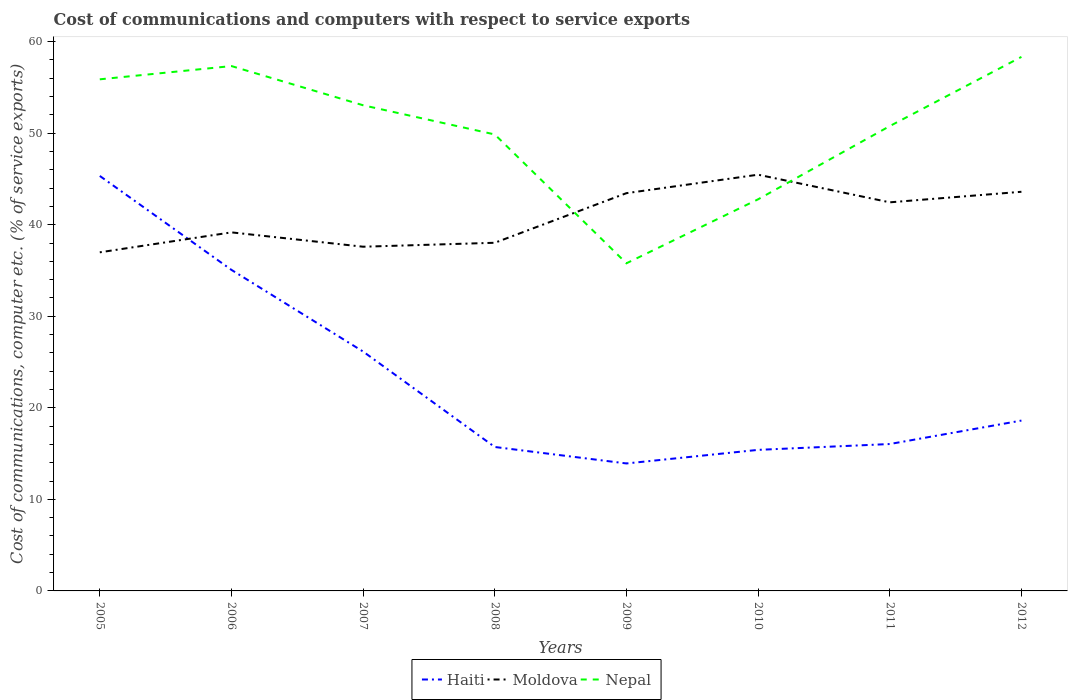How many different coloured lines are there?
Your answer should be very brief. 3. Across all years, what is the maximum cost of communications and computers in Moldova?
Your response must be concise. 36.99. What is the total cost of communications and computers in Haiti in the graph?
Offer a very short reply. -0.32. What is the difference between the highest and the second highest cost of communications and computers in Nepal?
Keep it short and to the point. 22.55. How many years are there in the graph?
Give a very brief answer. 8. Does the graph contain any zero values?
Keep it short and to the point. No. How are the legend labels stacked?
Keep it short and to the point. Horizontal. What is the title of the graph?
Keep it short and to the point. Cost of communications and computers with respect to service exports. Does "Ireland" appear as one of the legend labels in the graph?
Your response must be concise. No. What is the label or title of the X-axis?
Your answer should be compact. Years. What is the label or title of the Y-axis?
Offer a very short reply. Cost of communications, computer etc. (% of service exports). What is the Cost of communications, computer etc. (% of service exports) in Haiti in 2005?
Ensure brevity in your answer.  45.33. What is the Cost of communications, computer etc. (% of service exports) of Moldova in 2005?
Make the answer very short. 36.99. What is the Cost of communications, computer etc. (% of service exports) in Nepal in 2005?
Keep it short and to the point. 55.89. What is the Cost of communications, computer etc. (% of service exports) in Haiti in 2006?
Offer a terse response. 35.07. What is the Cost of communications, computer etc. (% of service exports) of Moldova in 2006?
Offer a terse response. 39.17. What is the Cost of communications, computer etc. (% of service exports) in Nepal in 2006?
Make the answer very short. 57.33. What is the Cost of communications, computer etc. (% of service exports) of Haiti in 2007?
Keep it short and to the point. 26.15. What is the Cost of communications, computer etc. (% of service exports) of Moldova in 2007?
Ensure brevity in your answer.  37.6. What is the Cost of communications, computer etc. (% of service exports) of Nepal in 2007?
Your response must be concise. 53.05. What is the Cost of communications, computer etc. (% of service exports) in Haiti in 2008?
Keep it short and to the point. 15.72. What is the Cost of communications, computer etc. (% of service exports) in Moldova in 2008?
Your answer should be very brief. 38.03. What is the Cost of communications, computer etc. (% of service exports) of Nepal in 2008?
Provide a short and direct response. 49.86. What is the Cost of communications, computer etc. (% of service exports) in Haiti in 2009?
Offer a very short reply. 13.92. What is the Cost of communications, computer etc. (% of service exports) of Moldova in 2009?
Your answer should be very brief. 43.45. What is the Cost of communications, computer etc. (% of service exports) in Nepal in 2009?
Provide a short and direct response. 35.79. What is the Cost of communications, computer etc. (% of service exports) of Haiti in 2010?
Your answer should be compact. 15.41. What is the Cost of communications, computer etc. (% of service exports) in Moldova in 2010?
Offer a terse response. 45.47. What is the Cost of communications, computer etc. (% of service exports) in Nepal in 2010?
Offer a very short reply. 42.78. What is the Cost of communications, computer etc. (% of service exports) of Haiti in 2011?
Offer a terse response. 16.05. What is the Cost of communications, computer etc. (% of service exports) of Moldova in 2011?
Offer a very short reply. 42.45. What is the Cost of communications, computer etc. (% of service exports) in Nepal in 2011?
Provide a short and direct response. 50.78. What is the Cost of communications, computer etc. (% of service exports) of Haiti in 2012?
Your answer should be compact. 18.61. What is the Cost of communications, computer etc. (% of service exports) in Moldova in 2012?
Offer a terse response. 43.6. What is the Cost of communications, computer etc. (% of service exports) in Nepal in 2012?
Your response must be concise. 58.33. Across all years, what is the maximum Cost of communications, computer etc. (% of service exports) of Haiti?
Offer a very short reply. 45.33. Across all years, what is the maximum Cost of communications, computer etc. (% of service exports) in Moldova?
Keep it short and to the point. 45.47. Across all years, what is the maximum Cost of communications, computer etc. (% of service exports) of Nepal?
Ensure brevity in your answer.  58.33. Across all years, what is the minimum Cost of communications, computer etc. (% of service exports) of Haiti?
Offer a terse response. 13.92. Across all years, what is the minimum Cost of communications, computer etc. (% of service exports) in Moldova?
Offer a terse response. 36.99. Across all years, what is the minimum Cost of communications, computer etc. (% of service exports) in Nepal?
Provide a short and direct response. 35.79. What is the total Cost of communications, computer etc. (% of service exports) of Haiti in the graph?
Make the answer very short. 186.26. What is the total Cost of communications, computer etc. (% of service exports) in Moldova in the graph?
Keep it short and to the point. 326.75. What is the total Cost of communications, computer etc. (% of service exports) of Nepal in the graph?
Your response must be concise. 403.81. What is the difference between the Cost of communications, computer etc. (% of service exports) of Haiti in 2005 and that in 2006?
Ensure brevity in your answer.  10.26. What is the difference between the Cost of communications, computer etc. (% of service exports) of Moldova in 2005 and that in 2006?
Give a very brief answer. -2.18. What is the difference between the Cost of communications, computer etc. (% of service exports) of Nepal in 2005 and that in 2006?
Your answer should be very brief. -1.45. What is the difference between the Cost of communications, computer etc. (% of service exports) in Haiti in 2005 and that in 2007?
Your response must be concise. 19.18. What is the difference between the Cost of communications, computer etc. (% of service exports) in Moldova in 2005 and that in 2007?
Offer a very short reply. -0.61. What is the difference between the Cost of communications, computer etc. (% of service exports) of Nepal in 2005 and that in 2007?
Provide a succinct answer. 2.83. What is the difference between the Cost of communications, computer etc. (% of service exports) of Haiti in 2005 and that in 2008?
Give a very brief answer. 29.61. What is the difference between the Cost of communications, computer etc. (% of service exports) in Moldova in 2005 and that in 2008?
Make the answer very short. -1.04. What is the difference between the Cost of communications, computer etc. (% of service exports) of Nepal in 2005 and that in 2008?
Give a very brief answer. 6.02. What is the difference between the Cost of communications, computer etc. (% of service exports) in Haiti in 2005 and that in 2009?
Give a very brief answer. 31.41. What is the difference between the Cost of communications, computer etc. (% of service exports) in Moldova in 2005 and that in 2009?
Your answer should be compact. -6.46. What is the difference between the Cost of communications, computer etc. (% of service exports) of Nepal in 2005 and that in 2009?
Your answer should be very brief. 20.1. What is the difference between the Cost of communications, computer etc. (% of service exports) of Haiti in 2005 and that in 2010?
Offer a very short reply. 29.92. What is the difference between the Cost of communications, computer etc. (% of service exports) in Moldova in 2005 and that in 2010?
Make the answer very short. -8.48. What is the difference between the Cost of communications, computer etc. (% of service exports) in Nepal in 2005 and that in 2010?
Your answer should be compact. 13.11. What is the difference between the Cost of communications, computer etc. (% of service exports) in Haiti in 2005 and that in 2011?
Offer a terse response. 29.29. What is the difference between the Cost of communications, computer etc. (% of service exports) in Moldova in 2005 and that in 2011?
Your response must be concise. -5.46. What is the difference between the Cost of communications, computer etc. (% of service exports) of Nepal in 2005 and that in 2011?
Your answer should be compact. 5.11. What is the difference between the Cost of communications, computer etc. (% of service exports) of Haiti in 2005 and that in 2012?
Your answer should be very brief. 26.72. What is the difference between the Cost of communications, computer etc. (% of service exports) of Moldova in 2005 and that in 2012?
Keep it short and to the point. -6.61. What is the difference between the Cost of communications, computer etc. (% of service exports) in Nepal in 2005 and that in 2012?
Offer a very short reply. -2.45. What is the difference between the Cost of communications, computer etc. (% of service exports) of Haiti in 2006 and that in 2007?
Offer a terse response. 8.92. What is the difference between the Cost of communications, computer etc. (% of service exports) in Moldova in 2006 and that in 2007?
Make the answer very short. 1.57. What is the difference between the Cost of communications, computer etc. (% of service exports) of Nepal in 2006 and that in 2007?
Ensure brevity in your answer.  4.28. What is the difference between the Cost of communications, computer etc. (% of service exports) in Haiti in 2006 and that in 2008?
Your response must be concise. 19.35. What is the difference between the Cost of communications, computer etc. (% of service exports) of Moldova in 2006 and that in 2008?
Give a very brief answer. 1.14. What is the difference between the Cost of communications, computer etc. (% of service exports) in Nepal in 2006 and that in 2008?
Provide a succinct answer. 7.47. What is the difference between the Cost of communications, computer etc. (% of service exports) in Haiti in 2006 and that in 2009?
Provide a succinct answer. 21.14. What is the difference between the Cost of communications, computer etc. (% of service exports) in Moldova in 2006 and that in 2009?
Provide a short and direct response. -4.28. What is the difference between the Cost of communications, computer etc. (% of service exports) of Nepal in 2006 and that in 2009?
Your response must be concise. 21.54. What is the difference between the Cost of communications, computer etc. (% of service exports) in Haiti in 2006 and that in 2010?
Your answer should be compact. 19.66. What is the difference between the Cost of communications, computer etc. (% of service exports) in Moldova in 2006 and that in 2010?
Ensure brevity in your answer.  -6.3. What is the difference between the Cost of communications, computer etc. (% of service exports) in Nepal in 2006 and that in 2010?
Provide a short and direct response. 14.56. What is the difference between the Cost of communications, computer etc. (% of service exports) of Haiti in 2006 and that in 2011?
Your answer should be compact. 19.02. What is the difference between the Cost of communications, computer etc. (% of service exports) of Moldova in 2006 and that in 2011?
Ensure brevity in your answer.  -3.28. What is the difference between the Cost of communications, computer etc. (% of service exports) in Nepal in 2006 and that in 2011?
Your answer should be very brief. 6.56. What is the difference between the Cost of communications, computer etc. (% of service exports) of Haiti in 2006 and that in 2012?
Your answer should be very brief. 16.46. What is the difference between the Cost of communications, computer etc. (% of service exports) of Moldova in 2006 and that in 2012?
Give a very brief answer. -4.43. What is the difference between the Cost of communications, computer etc. (% of service exports) in Nepal in 2006 and that in 2012?
Ensure brevity in your answer.  -1. What is the difference between the Cost of communications, computer etc. (% of service exports) in Haiti in 2007 and that in 2008?
Offer a terse response. 10.43. What is the difference between the Cost of communications, computer etc. (% of service exports) of Moldova in 2007 and that in 2008?
Ensure brevity in your answer.  -0.43. What is the difference between the Cost of communications, computer etc. (% of service exports) in Nepal in 2007 and that in 2008?
Offer a very short reply. 3.19. What is the difference between the Cost of communications, computer etc. (% of service exports) in Haiti in 2007 and that in 2009?
Provide a short and direct response. 12.22. What is the difference between the Cost of communications, computer etc. (% of service exports) of Moldova in 2007 and that in 2009?
Offer a very short reply. -5.85. What is the difference between the Cost of communications, computer etc. (% of service exports) in Nepal in 2007 and that in 2009?
Your answer should be compact. 17.26. What is the difference between the Cost of communications, computer etc. (% of service exports) in Haiti in 2007 and that in 2010?
Offer a very short reply. 10.74. What is the difference between the Cost of communications, computer etc. (% of service exports) in Moldova in 2007 and that in 2010?
Offer a terse response. -7.87. What is the difference between the Cost of communications, computer etc. (% of service exports) in Nepal in 2007 and that in 2010?
Keep it short and to the point. 10.27. What is the difference between the Cost of communications, computer etc. (% of service exports) in Haiti in 2007 and that in 2011?
Provide a succinct answer. 10.1. What is the difference between the Cost of communications, computer etc. (% of service exports) of Moldova in 2007 and that in 2011?
Offer a very short reply. -4.85. What is the difference between the Cost of communications, computer etc. (% of service exports) of Nepal in 2007 and that in 2011?
Provide a succinct answer. 2.27. What is the difference between the Cost of communications, computer etc. (% of service exports) of Haiti in 2007 and that in 2012?
Keep it short and to the point. 7.54. What is the difference between the Cost of communications, computer etc. (% of service exports) of Moldova in 2007 and that in 2012?
Your response must be concise. -6. What is the difference between the Cost of communications, computer etc. (% of service exports) in Nepal in 2007 and that in 2012?
Provide a short and direct response. -5.28. What is the difference between the Cost of communications, computer etc. (% of service exports) in Haiti in 2008 and that in 2009?
Make the answer very short. 1.8. What is the difference between the Cost of communications, computer etc. (% of service exports) in Moldova in 2008 and that in 2009?
Ensure brevity in your answer.  -5.42. What is the difference between the Cost of communications, computer etc. (% of service exports) of Nepal in 2008 and that in 2009?
Your response must be concise. 14.07. What is the difference between the Cost of communications, computer etc. (% of service exports) of Haiti in 2008 and that in 2010?
Provide a succinct answer. 0.31. What is the difference between the Cost of communications, computer etc. (% of service exports) in Moldova in 2008 and that in 2010?
Your response must be concise. -7.44. What is the difference between the Cost of communications, computer etc. (% of service exports) of Nepal in 2008 and that in 2010?
Give a very brief answer. 7.09. What is the difference between the Cost of communications, computer etc. (% of service exports) in Haiti in 2008 and that in 2011?
Offer a very short reply. -0.32. What is the difference between the Cost of communications, computer etc. (% of service exports) in Moldova in 2008 and that in 2011?
Your response must be concise. -4.42. What is the difference between the Cost of communications, computer etc. (% of service exports) of Nepal in 2008 and that in 2011?
Give a very brief answer. -0.91. What is the difference between the Cost of communications, computer etc. (% of service exports) of Haiti in 2008 and that in 2012?
Ensure brevity in your answer.  -2.89. What is the difference between the Cost of communications, computer etc. (% of service exports) of Moldova in 2008 and that in 2012?
Offer a very short reply. -5.57. What is the difference between the Cost of communications, computer etc. (% of service exports) of Nepal in 2008 and that in 2012?
Give a very brief answer. -8.47. What is the difference between the Cost of communications, computer etc. (% of service exports) of Haiti in 2009 and that in 2010?
Make the answer very short. -1.48. What is the difference between the Cost of communications, computer etc. (% of service exports) in Moldova in 2009 and that in 2010?
Your response must be concise. -2.02. What is the difference between the Cost of communications, computer etc. (% of service exports) in Nepal in 2009 and that in 2010?
Offer a terse response. -6.99. What is the difference between the Cost of communications, computer etc. (% of service exports) in Haiti in 2009 and that in 2011?
Give a very brief answer. -2.12. What is the difference between the Cost of communications, computer etc. (% of service exports) of Moldova in 2009 and that in 2011?
Offer a very short reply. 1. What is the difference between the Cost of communications, computer etc. (% of service exports) in Nepal in 2009 and that in 2011?
Give a very brief answer. -14.99. What is the difference between the Cost of communications, computer etc. (% of service exports) in Haiti in 2009 and that in 2012?
Your response must be concise. -4.68. What is the difference between the Cost of communications, computer etc. (% of service exports) in Moldova in 2009 and that in 2012?
Keep it short and to the point. -0.15. What is the difference between the Cost of communications, computer etc. (% of service exports) in Nepal in 2009 and that in 2012?
Offer a very short reply. -22.55. What is the difference between the Cost of communications, computer etc. (% of service exports) of Haiti in 2010 and that in 2011?
Your answer should be very brief. -0.64. What is the difference between the Cost of communications, computer etc. (% of service exports) of Moldova in 2010 and that in 2011?
Keep it short and to the point. 3.02. What is the difference between the Cost of communications, computer etc. (% of service exports) of Nepal in 2010 and that in 2011?
Give a very brief answer. -8. What is the difference between the Cost of communications, computer etc. (% of service exports) of Haiti in 2010 and that in 2012?
Your answer should be compact. -3.2. What is the difference between the Cost of communications, computer etc. (% of service exports) in Moldova in 2010 and that in 2012?
Offer a terse response. 1.87. What is the difference between the Cost of communications, computer etc. (% of service exports) in Nepal in 2010 and that in 2012?
Offer a terse response. -15.56. What is the difference between the Cost of communications, computer etc. (% of service exports) in Haiti in 2011 and that in 2012?
Your answer should be very brief. -2.56. What is the difference between the Cost of communications, computer etc. (% of service exports) in Moldova in 2011 and that in 2012?
Offer a very short reply. -1.15. What is the difference between the Cost of communications, computer etc. (% of service exports) in Nepal in 2011 and that in 2012?
Your answer should be very brief. -7.56. What is the difference between the Cost of communications, computer etc. (% of service exports) of Haiti in 2005 and the Cost of communications, computer etc. (% of service exports) of Moldova in 2006?
Make the answer very short. 6.17. What is the difference between the Cost of communications, computer etc. (% of service exports) in Haiti in 2005 and the Cost of communications, computer etc. (% of service exports) in Nepal in 2006?
Your answer should be compact. -12. What is the difference between the Cost of communications, computer etc. (% of service exports) in Moldova in 2005 and the Cost of communications, computer etc. (% of service exports) in Nepal in 2006?
Provide a short and direct response. -20.35. What is the difference between the Cost of communications, computer etc. (% of service exports) in Haiti in 2005 and the Cost of communications, computer etc. (% of service exports) in Moldova in 2007?
Your response must be concise. 7.73. What is the difference between the Cost of communications, computer etc. (% of service exports) of Haiti in 2005 and the Cost of communications, computer etc. (% of service exports) of Nepal in 2007?
Your answer should be very brief. -7.72. What is the difference between the Cost of communications, computer etc. (% of service exports) in Moldova in 2005 and the Cost of communications, computer etc. (% of service exports) in Nepal in 2007?
Give a very brief answer. -16.06. What is the difference between the Cost of communications, computer etc. (% of service exports) of Haiti in 2005 and the Cost of communications, computer etc. (% of service exports) of Moldova in 2008?
Ensure brevity in your answer.  7.3. What is the difference between the Cost of communications, computer etc. (% of service exports) in Haiti in 2005 and the Cost of communications, computer etc. (% of service exports) in Nepal in 2008?
Keep it short and to the point. -4.53. What is the difference between the Cost of communications, computer etc. (% of service exports) of Moldova in 2005 and the Cost of communications, computer etc. (% of service exports) of Nepal in 2008?
Ensure brevity in your answer.  -12.88. What is the difference between the Cost of communications, computer etc. (% of service exports) of Haiti in 2005 and the Cost of communications, computer etc. (% of service exports) of Moldova in 2009?
Keep it short and to the point. 1.88. What is the difference between the Cost of communications, computer etc. (% of service exports) of Haiti in 2005 and the Cost of communications, computer etc. (% of service exports) of Nepal in 2009?
Your answer should be very brief. 9.54. What is the difference between the Cost of communications, computer etc. (% of service exports) of Moldova in 2005 and the Cost of communications, computer etc. (% of service exports) of Nepal in 2009?
Give a very brief answer. 1.2. What is the difference between the Cost of communications, computer etc. (% of service exports) in Haiti in 2005 and the Cost of communications, computer etc. (% of service exports) in Moldova in 2010?
Provide a succinct answer. -0.14. What is the difference between the Cost of communications, computer etc. (% of service exports) in Haiti in 2005 and the Cost of communications, computer etc. (% of service exports) in Nepal in 2010?
Keep it short and to the point. 2.55. What is the difference between the Cost of communications, computer etc. (% of service exports) of Moldova in 2005 and the Cost of communications, computer etc. (% of service exports) of Nepal in 2010?
Your answer should be compact. -5.79. What is the difference between the Cost of communications, computer etc. (% of service exports) in Haiti in 2005 and the Cost of communications, computer etc. (% of service exports) in Moldova in 2011?
Provide a succinct answer. 2.88. What is the difference between the Cost of communications, computer etc. (% of service exports) in Haiti in 2005 and the Cost of communications, computer etc. (% of service exports) in Nepal in 2011?
Make the answer very short. -5.44. What is the difference between the Cost of communications, computer etc. (% of service exports) of Moldova in 2005 and the Cost of communications, computer etc. (% of service exports) of Nepal in 2011?
Your response must be concise. -13.79. What is the difference between the Cost of communications, computer etc. (% of service exports) of Haiti in 2005 and the Cost of communications, computer etc. (% of service exports) of Moldova in 2012?
Offer a terse response. 1.73. What is the difference between the Cost of communications, computer etc. (% of service exports) in Haiti in 2005 and the Cost of communications, computer etc. (% of service exports) in Nepal in 2012?
Ensure brevity in your answer.  -13. What is the difference between the Cost of communications, computer etc. (% of service exports) of Moldova in 2005 and the Cost of communications, computer etc. (% of service exports) of Nepal in 2012?
Provide a short and direct response. -21.35. What is the difference between the Cost of communications, computer etc. (% of service exports) of Haiti in 2006 and the Cost of communications, computer etc. (% of service exports) of Moldova in 2007?
Offer a terse response. -2.53. What is the difference between the Cost of communications, computer etc. (% of service exports) of Haiti in 2006 and the Cost of communications, computer etc. (% of service exports) of Nepal in 2007?
Keep it short and to the point. -17.98. What is the difference between the Cost of communications, computer etc. (% of service exports) in Moldova in 2006 and the Cost of communications, computer etc. (% of service exports) in Nepal in 2007?
Your answer should be very brief. -13.88. What is the difference between the Cost of communications, computer etc. (% of service exports) in Haiti in 2006 and the Cost of communications, computer etc. (% of service exports) in Moldova in 2008?
Your answer should be compact. -2.96. What is the difference between the Cost of communications, computer etc. (% of service exports) of Haiti in 2006 and the Cost of communications, computer etc. (% of service exports) of Nepal in 2008?
Keep it short and to the point. -14.79. What is the difference between the Cost of communications, computer etc. (% of service exports) of Moldova in 2006 and the Cost of communications, computer etc. (% of service exports) of Nepal in 2008?
Offer a terse response. -10.7. What is the difference between the Cost of communications, computer etc. (% of service exports) of Haiti in 2006 and the Cost of communications, computer etc. (% of service exports) of Moldova in 2009?
Your response must be concise. -8.38. What is the difference between the Cost of communications, computer etc. (% of service exports) of Haiti in 2006 and the Cost of communications, computer etc. (% of service exports) of Nepal in 2009?
Your answer should be compact. -0.72. What is the difference between the Cost of communications, computer etc. (% of service exports) in Moldova in 2006 and the Cost of communications, computer etc. (% of service exports) in Nepal in 2009?
Keep it short and to the point. 3.38. What is the difference between the Cost of communications, computer etc. (% of service exports) of Haiti in 2006 and the Cost of communications, computer etc. (% of service exports) of Moldova in 2010?
Keep it short and to the point. -10.4. What is the difference between the Cost of communications, computer etc. (% of service exports) of Haiti in 2006 and the Cost of communications, computer etc. (% of service exports) of Nepal in 2010?
Give a very brief answer. -7.71. What is the difference between the Cost of communications, computer etc. (% of service exports) in Moldova in 2006 and the Cost of communications, computer etc. (% of service exports) in Nepal in 2010?
Give a very brief answer. -3.61. What is the difference between the Cost of communications, computer etc. (% of service exports) of Haiti in 2006 and the Cost of communications, computer etc. (% of service exports) of Moldova in 2011?
Keep it short and to the point. -7.38. What is the difference between the Cost of communications, computer etc. (% of service exports) in Haiti in 2006 and the Cost of communications, computer etc. (% of service exports) in Nepal in 2011?
Give a very brief answer. -15.71. What is the difference between the Cost of communications, computer etc. (% of service exports) of Moldova in 2006 and the Cost of communications, computer etc. (% of service exports) of Nepal in 2011?
Provide a succinct answer. -11.61. What is the difference between the Cost of communications, computer etc. (% of service exports) in Haiti in 2006 and the Cost of communications, computer etc. (% of service exports) in Moldova in 2012?
Provide a succinct answer. -8.53. What is the difference between the Cost of communications, computer etc. (% of service exports) in Haiti in 2006 and the Cost of communications, computer etc. (% of service exports) in Nepal in 2012?
Make the answer very short. -23.27. What is the difference between the Cost of communications, computer etc. (% of service exports) in Moldova in 2006 and the Cost of communications, computer etc. (% of service exports) in Nepal in 2012?
Offer a terse response. -19.17. What is the difference between the Cost of communications, computer etc. (% of service exports) in Haiti in 2007 and the Cost of communications, computer etc. (% of service exports) in Moldova in 2008?
Ensure brevity in your answer.  -11.88. What is the difference between the Cost of communications, computer etc. (% of service exports) in Haiti in 2007 and the Cost of communications, computer etc. (% of service exports) in Nepal in 2008?
Your answer should be compact. -23.72. What is the difference between the Cost of communications, computer etc. (% of service exports) in Moldova in 2007 and the Cost of communications, computer etc. (% of service exports) in Nepal in 2008?
Give a very brief answer. -12.26. What is the difference between the Cost of communications, computer etc. (% of service exports) in Haiti in 2007 and the Cost of communications, computer etc. (% of service exports) in Moldova in 2009?
Your response must be concise. -17.3. What is the difference between the Cost of communications, computer etc. (% of service exports) of Haiti in 2007 and the Cost of communications, computer etc. (% of service exports) of Nepal in 2009?
Your response must be concise. -9.64. What is the difference between the Cost of communications, computer etc. (% of service exports) of Moldova in 2007 and the Cost of communications, computer etc. (% of service exports) of Nepal in 2009?
Your answer should be very brief. 1.81. What is the difference between the Cost of communications, computer etc. (% of service exports) in Haiti in 2007 and the Cost of communications, computer etc. (% of service exports) in Moldova in 2010?
Offer a very short reply. -19.32. What is the difference between the Cost of communications, computer etc. (% of service exports) in Haiti in 2007 and the Cost of communications, computer etc. (% of service exports) in Nepal in 2010?
Give a very brief answer. -16.63. What is the difference between the Cost of communications, computer etc. (% of service exports) of Moldova in 2007 and the Cost of communications, computer etc. (% of service exports) of Nepal in 2010?
Provide a short and direct response. -5.18. What is the difference between the Cost of communications, computer etc. (% of service exports) of Haiti in 2007 and the Cost of communications, computer etc. (% of service exports) of Moldova in 2011?
Offer a very short reply. -16.3. What is the difference between the Cost of communications, computer etc. (% of service exports) of Haiti in 2007 and the Cost of communications, computer etc. (% of service exports) of Nepal in 2011?
Your answer should be very brief. -24.63. What is the difference between the Cost of communications, computer etc. (% of service exports) of Moldova in 2007 and the Cost of communications, computer etc. (% of service exports) of Nepal in 2011?
Your response must be concise. -13.18. What is the difference between the Cost of communications, computer etc. (% of service exports) in Haiti in 2007 and the Cost of communications, computer etc. (% of service exports) in Moldova in 2012?
Provide a short and direct response. -17.45. What is the difference between the Cost of communications, computer etc. (% of service exports) in Haiti in 2007 and the Cost of communications, computer etc. (% of service exports) in Nepal in 2012?
Your answer should be compact. -32.19. What is the difference between the Cost of communications, computer etc. (% of service exports) in Moldova in 2007 and the Cost of communications, computer etc. (% of service exports) in Nepal in 2012?
Offer a terse response. -20.73. What is the difference between the Cost of communications, computer etc. (% of service exports) of Haiti in 2008 and the Cost of communications, computer etc. (% of service exports) of Moldova in 2009?
Ensure brevity in your answer.  -27.73. What is the difference between the Cost of communications, computer etc. (% of service exports) of Haiti in 2008 and the Cost of communications, computer etc. (% of service exports) of Nepal in 2009?
Ensure brevity in your answer.  -20.07. What is the difference between the Cost of communications, computer etc. (% of service exports) of Moldova in 2008 and the Cost of communications, computer etc. (% of service exports) of Nepal in 2009?
Provide a short and direct response. 2.24. What is the difference between the Cost of communications, computer etc. (% of service exports) in Haiti in 2008 and the Cost of communications, computer etc. (% of service exports) in Moldova in 2010?
Offer a terse response. -29.75. What is the difference between the Cost of communications, computer etc. (% of service exports) in Haiti in 2008 and the Cost of communications, computer etc. (% of service exports) in Nepal in 2010?
Offer a terse response. -27.06. What is the difference between the Cost of communications, computer etc. (% of service exports) of Moldova in 2008 and the Cost of communications, computer etc. (% of service exports) of Nepal in 2010?
Your answer should be compact. -4.75. What is the difference between the Cost of communications, computer etc. (% of service exports) in Haiti in 2008 and the Cost of communications, computer etc. (% of service exports) in Moldova in 2011?
Offer a terse response. -26.73. What is the difference between the Cost of communications, computer etc. (% of service exports) of Haiti in 2008 and the Cost of communications, computer etc. (% of service exports) of Nepal in 2011?
Your answer should be very brief. -35.05. What is the difference between the Cost of communications, computer etc. (% of service exports) of Moldova in 2008 and the Cost of communications, computer etc. (% of service exports) of Nepal in 2011?
Provide a short and direct response. -12.75. What is the difference between the Cost of communications, computer etc. (% of service exports) in Haiti in 2008 and the Cost of communications, computer etc. (% of service exports) in Moldova in 2012?
Make the answer very short. -27.88. What is the difference between the Cost of communications, computer etc. (% of service exports) of Haiti in 2008 and the Cost of communications, computer etc. (% of service exports) of Nepal in 2012?
Give a very brief answer. -42.61. What is the difference between the Cost of communications, computer etc. (% of service exports) in Moldova in 2008 and the Cost of communications, computer etc. (% of service exports) in Nepal in 2012?
Ensure brevity in your answer.  -20.3. What is the difference between the Cost of communications, computer etc. (% of service exports) in Haiti in 2009 and the Cost of communications, computer etc. (% of service exports) in Moldova in 2010?
Make the answer very short. -31.54. What is the difference between the Cost of communications, computer etc. (% of service exports) in Haiti in 2009 and the Cost of communications, computer etc. (% of service exports) in Nepal in 2010?
Provide a succinct answer. -28.85. What is the difference between the Cost of communications, computer etc. (% of service exports) of Moldova in 2009 and the Cost of communications, computer etc. (% of service exports) of Nepal in 2010?
Give a very brief answer. 0.67. What is the difference between the Cost of communications, computer etc. (% of service exports) in Haiti in 2009 and the Cost of communications, computer etc. (% of service exports) in Moldova in 2011?
Make the answer very short. -28.52. What is the difference between the Cost of communications, computer etc. (% of service exports) of Haiti in 2009 and the Cost of communications, computer etc. (% of service exports) of Nepal in 2011?
Your response must be concise. -36.85. What is the difference between the Cost of communications, computer etc. (% of service exports) in Moldova in 2009 and the Cost of communications, computer etc. (% of service exports) in Nepal in 2011?
Your answer should be very brief. -7.33. What is the difference between the Cost of communications, computer etc. (% of service exports) of Haiti in 2009 and the Cost of communications, computer etc. (% of service exports) of Moldova in 2012?
Your answer should be compact. -29.68. What is the difference between the Cost of communications, computer etc. (% of service exports) in Haiti in 2009 and the Cost of communications, computer etc. (% of service exports) in Nepal in 2012?
Your answer should be very brief. -44.41. What is the difference between the Cost of communications, computer etc. (% of service exports) in Moldova in 2009 and the Cost of communications, computer etc. (% of service exports) in Nepal in 2012?
Give a very brief answer. -14.88. What is the difference between the Cost of communications, computer etc. (% of service exports) of Haiti in 2010 and the Cost of communications, computer etc. (% of service exports) of Moldova in 2011?
Keep it short and to the point. -27.04. What is the difference between the Cost of communications, computer etc. (% of service exports) of Haiti in 2010 and the Cost of communications, computer etc. (% of service exports) of Nepal in 2011?
Offer a very short reply. -35.37. What is the difference between the Cost of communications, computer etc. (% of service exports) of Moldova in 2010 and the Cost of communications, computer etc. (% of service exports) of Nepal in 2011?
Your response must be concise. -5.31. What is the difference between the Cost of communications, computer etc. (% of service exports) in Haiti in 2010 and the Cost of communications, computer etc. (% of service exports) in Moldova in 2012?
Offer a very short reply. -28.19. What is the difference between the Cost of communications, computer etc. (% of service exports) in Haiti in 2010 and the Cost of communications, computer etc. (% of service exports) in Nepal in 2012?
Your answer should be very brief. -42.93. What is the difference between the Cost of communications, computer etc. (% of service exports) in Moldova in 2010 and the Cost of communications, computer etc. (% of service exports) in Nepal in 2012?
Your response must be concise. -12.87. What is the difference between the Cost of communications, computer etc. (% of service exports) in Haiti in 2011 and the Cost of communications, computer etc. (% of service exports) in Moldova in 2012?
Keep it short and to the point. -27.56. What is the difference between the Cost of communications, computer etc. (% of service exports) of Haiti in 2011 and the Cost of communications, computer etc. (% of service exports) of Nepal in 2012?
Keep it short and to the point. -42.29. What is the difference between the Cost of communications, computer etc. (% of service exports) in Moldova in 2011 and the Cost of communications, computer etc. (% of service exports) in Nepal in 2012?
Offer a terse response. -15.89. What is the average Cost of communications, computer etc. (% of service exports) in Haiti per year?
Your answer should be compact. 23.28. What is the average Cost of communications, computer etc. (% of service exports) of Moldova per year?
Provide a succinct answer. 40.84. What is the average Cost of communications, computer etc. (% of service exports) of Nepal per year?
Offer a very short reply. 50.48. In the year 2005, what is the difference between the Cost of communications, computer etc. (% of service exports) in Haiti and Cost of communications, computer etc. (% of service exports) in Moldova?
Your answer should be very brief. 8.34. In the year 2005, what is the difference between the Cost of communications, computer etc. (% of service exports) in Haiti and Cost of communications, computer etc. (% of service exports) in Nepal?
Make the answer very short. -10.55. In the year 2005, what is the difference between the Cost of communications, computer etc. (% of service exports) of Moldova and Cost of communications, computer etc. (% of service exports) of Nepal?
Offer a terse response. -18.9. In the year 2006, what is the difference between the Cost of communications, computer etc. (% of service exports) of Haiti and Cost of communications, computer etc. (% of service exports) of Moldova?
Provide a succinct answer. -4.1. In the year 2006, what is the difference between the Cost of communications, computer etc. (% of service exports) in Haiti and Cost of communications, computer etc. (% of service exports) in Nepal?
Make the answer very short. -22.26. In the year 2006, what is the difference between the Cost of communications, computer etc. (% of service exports) of Moldova and Cost of communications, computer etc. (% of service exports) of Nepal?
Keep it short and to the point. -18.17. In the year 2007, what is the difference between the Cost of communications, computer etc. (% of service exports) of Haiti and Cost of communications, computer etc. (% of service exports) of Moldova?
Ensure brevity in your answer.  -11.45. In the year 2007, what is the difference between the Cost of communications, computer etc. (% of service exports) of Haiti and Cost of communications, computer etc. (% of service exports) of Nepal?
Ensure brevity in your answer.  -26.9. In the year 2007, what is the difference between the Cost of communications, computer etc. (% of service exports) of Moldova and Cost of communications, computer etc. (% of service exports) of Nepal?
Offer a terse response. -15.45. In the year 2008, what is the difference between the Cost of communications, computer etc. (% of service exports) of Haiti and Cost of communications, computer etc. (% of service exports) of Moldova?
Make the answer very short. -22.31. In the year 2008, what is the difference between the Cost of communications, computer etc. (% of service exports) in Haiti and Cost of communications, computer etc. (% of service exports) in Nepal?
Keep it short and to the point. -34.14. In the year 2008, what is the difference between the Cost of communications, computer etc. (% of service exports) of Moldova and Cost of communications, computer etc. (% of service exports) of Nepal?
Your answer should be very brief. -11.83. In the year 2009, what is the difference between the Cost of communications, computer etc. (% of service exports) of Haiti and Cost of communications, computer etc. (% of service exports) of Moldova?
Your response must be concise. -29.53. In the year 2009, what is the difference between the Cost of communications, computer etc. (% of service exports) in Haiti and Cost of communications, computer etc. (% of service exports) in Nepal?
Offer a terse response. -21.86. In the year 2009, what is the difference between the Cost of communications, computer etc. (% of service exports) of Moldova and Cost of communications, computer etc. (% of service exports) of Nepal?
Offer a very short reply. 7.66. In the year 2010, what is the difference between the Cost of communications, computer etc. (% of service exports) in Haiti and Cost of communications, computer etc. (% of service exports) in Moldova?
Ensure brevity in your answer.  -30.06. In the year 2010, what is the difference between the Cost of communications, computer etc. (% of service exports) of Haiti and Cost of communications, computer etc. (% of service exports) of Nepal?
Offer a very short reply. -27.37. In the year 2010, what is the difference between the Cost of communications, computer etc. (% of service exports) of Moldova and Cost of communications, computer etc. (% of service exports) of Nepal?
Offer a very short reply. 2.69. In the year 2011, what is the difference between the Cost of communications, computer etc. (% of service exports) of Haiti and Cost of communications, computer etc. (% of service exports) of Moldova?
Your answer should be very brief. -26.4. In the year 2011, what is the difference between the Cost of communications, computer etc. (% of service exports) in Haiti and Cost of communications, computer etc. (% of service exports) in Nepal?
Offer a very short reply. -34.73. In the year 2011, what is the difference between the Cost of communications, computer etc. (% of service exports) in Moldova and Cost of communications, computer etc. (% of service exports) in Nepal?
Keep it short and to the point. -8.33. In the year 2012, what is the difference between the Cost of communications, computer etc. (% of service exports) in Haiti and Cost of communications, computer etc. (% of service exports) in Moldova?
Give a very brief answer. -24.99. In the year 2012, what is the difference between the Cost of communications, computer etc. (% of service exports) in Haiti and Cost of communications, computer etc. (% of service exports) in Nepal?
Your response must be concise. -39.73. In the year 2012, what is the difference between the Cost of communications, computer etc. (% of service exports) in Moldova and Cost of communications, computer etc. (% of service exports) in Nepal?
Your answer should be compact. -14.73. What is the ratio of the Cost of communications, computer etc. (% of service exports) of Haiti in 2005 to that in 2006?
Provide a succinct answer. 1.29. What is the ratio of the Cost of communications, computer etc. (% of service exports) in Nepal in 2005 to that in 2006?
Offer a terse response. 0.97. What is the ratio of the Cost of communications, computer etc. (% of service exports) of Haiti in 2005 to that in 2007?
Your answer should be very brief. 1.73. What is the ratio of the Cost of communications, computer etc. (% of service exports) of Moldova in 2005 to that in 2007?
Offer a terse response. 0.98. What is the ratio of the Cost of communications, computer etc. (% of service exports) of Nepal in 2005 to that in 2007?
Give a very brief answer. 1.05. What is the ratio of the Cost of communications, computer etc. (% of service exports) in Haiti in 2005 to that in 2008?
Provide a succinct answer. 2.88. What is the ratio of the Cost of communications, computer etc. (% of service exports) of Moldova in 2005 to that in 2008?
Offer a terse response. 0.97. What is the ratio of the Cost of communications, computer etc. (% of service exports) of Nepal in 2005 to that in 2008?
Offer a terse response. 1.12. What is the ratio of the Cost of communications, computer etc. (% of service exports) in Haiti in 2005 to that in 2009?
Provide a succinct answer. 3.26. What is the ratio of the Cost of communications, computer etc. (% of service exports) of Moldova in 2005 to that in 2009?
Provide a short and direct response. 0.85. What is the ratio of the Cost of communications, computer etc. (% of service exports) of Nepal in 2005 to that in 2009?
Provide a succinct answer. 1.56. What is the ratio of the Cost of communications, computer etc. (% of service exports) in Haiti in 2005 to that in 2010?
Offer a very short reply. 2.94. What is the ratio of the Cost of communications, computer etc. (% of service exports) in Moldova in 2005 to that in 2010?
Give a very brief answer. 0.81. What is the ratio of the Cost of communications, computer etc. (% of service exports) of Nepal in 2005 to that in 2010?
Provide a succinct answer. 1.31. What is the ratio of the Cost of communications, computer etc. (% of service exports) of Haiti in 2005 to that in 2011?
Your answer should be compact. 2.83. What is the ratio of the Cost of communications, computer etc. (% of service exports) of Moldova in 2005 to that in 2011?
Give a very brief answer. 0.87. What is the ratio of the Cost of communications, computer etc. (% of service exports) in Nepal in 2005 to that in 2011?
Make the answer very short. 1.1. What is the ratio of the Cost of communications, computer etc. (% of service exports) in Haiti in 2005 to that in 2012?
Your response must be concise. 2.44. What is the ratio of the Cost of communications, computer etc. (% of service exports) of Moldova in 2005 to that in 2012?
Your answer should be very brief. 0.85. What is the ratio of the Cost of communications, computer etc. (% of service exports) of Nepal in 2005 to that in 2012?
Offer a terse response. 0.96. What is the ratio of the Cost of communications, computer etc. (% of service exports) in Haiti in 2006 to that in 2007?
Keep it short and to the point. 1.34. What is the ratio of the Cost of communications, computer etc. (% of service exports) of Moldova in 2006 to that in 2007?
Make the answer very short. 1.04. What is the ratio of the Cost of communications, computer etc. (% of service exports) of Nepal in 2006 to that in 2007?
Offer a terse response. 1.08. What is the ratio of the Cost of communications, computer etc. (% of service exports) of Haiti in 2006 to that in 2008?
Make the answer very short. 2.23. What is the ratio of the Cost of communications, computer etc. (% of service exports) in Moldova in 2006 to that in 2008?
Your answer should be compact. 1.03. What is the ratio of the Cost of communications, computer etc. (% of service exports) in Nepal in 2006 to that in 2008?
Offer a terse response. 1.15. What is the ratio of the Cost of communications, computer etc. (% of service exports) of Haiti in 2006 to that in 2009?
Your response must be concise. 2.52. What is the ratio of the Cost of communications, computer etc. (% of service exports) of Moldova in 2006 to that in 2009?
Give a very brief answer. 0.9. What is the ratio of the Cost of communications, computer etc. (% of service exports) in Nepal in 2006 to that in 2009?
Make the answer very short. 1.6. What is the ratio of the Cost of communications, computer etc. (% of service exports) in Haiti in 2006 to that in 2010?
Offer a very short reply. 2.28. What is the ratio of the Cost of communications, computer etc. (% of service exports) of Moldova in 2006 to that in 2010?
Provide a short and direct response. 0.86. What is the ratio of the Cost of communications, computer etc. (% of service exports) in Nepal in 2006 to that in 2010?
Provide a short and direct response. 1.34. What is the ratio of the Cost of communications, computer etc. (% of service exports) in Haiti in 2006 to that in 2011?
Ensure brevity in your answer.  2.19. What is the ratio of the Cost of communications, computer etc. (% of service exports) in Moldova in 2006 to that in 2011?
Your answer should be compact. 0.92. What is the ratio of the Cost of communications, computer etc. (% of service exports) of Nepal in 2006 to that in 2011?
Your answer should be compact. 1.13. What is the ratio of the Cost of communications, computer etc. (% of service exports) in Haiti in 2006 to that in 2012?
Keep it short and to the point. 1.88. What is the ratio of the Cost of communications, computer etc. (% of service exports) in Moldova in 2006 to that in 2012?
Your response must be concise. 0.9. What is the ratio of the Cost of communications, computer etc. (% of service exports) of Nepal in 2006 to that in 2012?
Provide a succinct answer. 0.98. What is the ratio of the Cost of communications, computer etc. (% of service exports) of Haiti in 2007 to that in 2008?
Your answer should be compact. 1.66. What is the ratio of the Cost of communications, computer etc. (% of service exports) in Moldova in 2007 to that in 2008?
Ensure brevity in your answer.  0.99. What is the ratio of the Cost of communications, computer etc. (% of service exports) of Nepal in 2007 to that in 2008?
Offer a very short reply. 1.06. What is the ratio of the Cost of communications, computer etc. (% of service exports) of Haiti in 2007 to that in 2009?
Provide a short and direct response. 1.88. What is the ratio of the Cost of communications, computer etc. (% of service exports) in Moldova in 2007 to that in 2009?
Your answer should be compact. 0.87. What is the ratio of the Cost of communications, computer etc. (% of service exports) of Nepal in 2007 to that in 2009?
Make the answer very short. 1.48. What is the ratio of the Cost of communications, computer etc. (% of service exports) of Haiti in 2007 to that in 2010?
Offer a terse response. 1.7. What is the ratio of the Cost of communications, computer etc. (% of service exports) in Moldova in 2007 to that in 2010?
Make the answer very short. 0.83. What is the ratio of the Cost of communications, computer etc. (% of service exports) of Nepal in 2007 to that in 2010?
Your answer should be compact. 1.24. What is the ratio of the Cost of communications, computer etc. (% of service exports) of Haiti in 2007 to that in 2011?
Keep it short and to the point. 1.63. What is the ratio of the Cost of communications, computer etc. (% of service exports) in Moldova in 2007 to that in 2011?
Provide a succinct answer. 0.89. What is the ratio of the Cost of communications, computer etc. (% of service exports) of Nepal in 2007 to that in 2011?
Offer a very short reply. 1.04. What is the ratio of the Cost of communications, computer etc. (% of service exports) in Haiti in 2007 to that in 2012?
Provide a short and direct response. 1.41. What is the ratio of the Cost of communications, computer etc. (% of service exports) of Moldova in 2007 to that in 2012?
Your answer should be compact. 0.86. What is the ratio of the Cost of communications, computer etc. (% of service exports) in Nepal in 2007 to that in 2012?
Provide a succinct answer. 0.91. What is the ratio of the Cost of communications, computer etc. (% of service exports) of Haiti in 2008 to that in 2009?
Offer a terse response. 1.13. What is the ratio of the Cost of communications, computer etc. (% of service exports) in Moldova in 2008 to that in 2009?
Offer a very short reply. 0.88. What is the ratio of the Cost of communications, computer etc. (% of service exports) of Nepal in 2008 to that in 2009?
Make the answer very short. 1.39. What is the ratio of the Cost of communications, computer etc. (% of service exports) of Haiti in 2008 to that in 2010?
Your answer should be compact. 1.02. What is the ratio of the Cost of communications, computer etc. (% of service exports) of Moldova in 2008 to that in 2010?
Offer a very short reply. 0.84. What is the ratio of the Cost of communications, computer etc. (% of service exports) of Nepal in 2008 to that in 2010?
Your answer should be compact. 1.17. What is the ratio of the Cost of communications, computer etc. (% of service exports) of Haiti in 2008 to that in 2011?
Your answer should be very brief. 0.98. What is the ratio of the Cost of communications, computer etc. (% of service exports) in Moldova in 2008 to that in 2011?
Provide a succinct answer. 0.9. What is the ratio of the Cost of communications, computer etc. (% of service exports) in Haiti in 2008 to that in 2012?
Offer a very short reply. 0.84. What is the ratio of the Cost of communications, computer etc. (% of service exports) of Moldova in 2008 to that in 2012?
Provide a succinct answer. 0.87. What is the ratio of the Cost of communications, computer etc. (% of service exports) of Nepal in 2008 to that in 2012?
Offer a very short reply. 0.85. What is the ratio of the Cost of communications, computer etc. (% of service exports) in Haiti in 2009 to that in 2010?
Keep it short and to the point. 0.9. What is the ratio of the Cost of communications, computer etc. (% of service exports) of Moldova in 2009 to that in 2010?
Your answer should be very brief. 0.96. What is the ratio of the Cost of communications, computer etc. (% of service exports) in Nepal in 2009 to that in 2010?
Offer a very short reply. 0.84. What is the ratio of the Cost of communications, computer etc. (% of service exports) in Haiti in 2009 to that in 2011?
Your answer should be very brief. 0.87. What is the ratio of the Cost of communications, computer etc. (% of service exports) of Moldova in 2009 to that in 2011?
Your answer should be compact. 1.02. What is the ratio of the Cost of communications, computer etc. (% of service exports) in Nepal in 2009 to that in 2011?
Provide a short and direct response. 0.7. What is the ratio of the Cost of communications, computer etc. (% of service exports) of Haiti in 2009 to that in 2012?
Provide a short and direct response. 0.75. What is the ratio of the Cost of communications, computer etc. (% of service exports) in Nepal in 2009 to that in 2012?
Ensure brevity in your answer.  0.61. What is the ratio of the Cost of communications, computer etc. (% of service exports) in Haiti in 2010 to that in 2011?
Ensure brevity in your answer.  0.96. What is the ratio of the Cost of communications, computer etc. (% of service exports) of Moldova in 2010 to that in 2011?
Give a very brief answer. 1.07. What is the ratio of the Cost of communications, computer etc. (% of service exports) of Nepal in 2010 to that in 2011?
Provide a short and direct response. 0.84. What is the ratio of the Cost of communications, computer etc. (% of service exports) in Haiti in 2010 to that in 2012?
Make the answer very short. 0.83. What is the ratio of the Cost of communications, computer etc. (% of service exports) of Moldova in 2010 to that in 2012?
Provide a succinct answer. 1.04. What is the ratio of the Cost of communications, computer etc. (% of service exports) of Nepal in 2010 to that in 2012?
Make the answer very short. 0.73. What is the ratio of the Cost of communications, computer etc. (% of service exports) of Haiti in 2011 to that in 2012?
Offer a terse response. 0.86. What is the ratio of the Cost of communications, computer etc. (% of service exports) of Moldova in 2011 to that in 2012?
Offer a very short reply. 0.97. What is the ratio of the Cost of communications, computer etc. (% of service exports) of Nepal in 2011 to that in 2012?
Your answer should be very brief. 0.87. What is the difference between the highest and the second highest Cost of communications, computer etc. (% of service exports) of Haiti?
Make the answer very short. 10.26. What is the difference between the highest and the second highest Cost of communications, computer etc. (% of service exports) of Moldova?
Provide a short and direct response. 1.87. What is the difference between the highest and the second highest Cost of communications, computer etc. (% of service exports) of Nepal?
Your answer should be compact. 1. What is the difference between the highest and the lowest Cost of communications, computer etc. (% of service exports) in Haiti?
Keep it short and to the point. 31.41. What is the difference between the highest and the lowest Cost of communications, computer etc. (% of service exports) in Moldova?
Keep it short and to the point. 8.48. What is the difference between the highest and the lowest Cost of communications, computer etc. (% of service exports) in Nepal?
Your response must be concise. 22.55. 